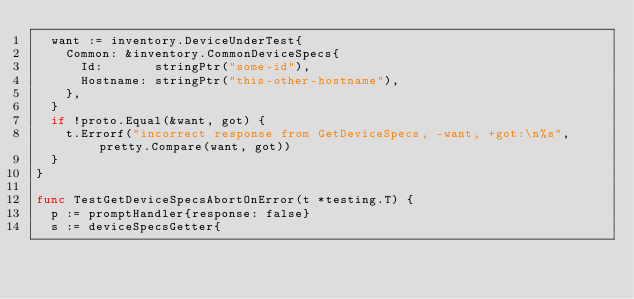<code> <loc_0><loc_0><loc_500><loc_500><_Go_>	want := inventory.DeviceUnderTest{
		Common: &inventory.CommonDeviceSpecs{
			Id:       stringPtr("some-id"),
			Hostname: stringPtr("this-other-hostname"),
		},
	}
	if !proto.Equal(&want, got) {
		t.Errorf("incorrect response from GetDeviceSpecs, -want, +got:\n%s", pretty.Compare(want, got))
	}
}

func TestGetDeviceSpecsAbortOnError(t *testing.T) {
	p := promptHandler{response: false}
	s := deviceSpecsGetter{</code> 